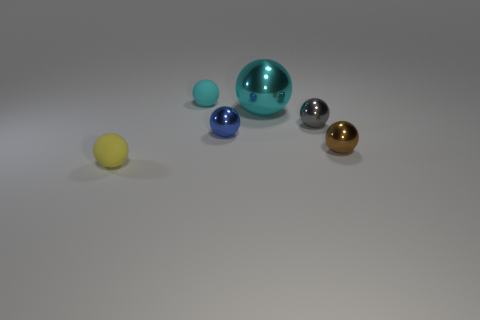How many cyan spheres must be subtracted to get 1 cyan spheres? 1 Add 3 large cyan shiny spheres. How many objects exist? 9 Subtract all brown metallic balls. How many balls are left? 5 Subtract 1 spheres. How many spheres are left? 5 Add 6 tiny rubber balls. How many tiny rubber balls exist? 8 Subtract all cyan balls. How many balls are left? 4 Subtract 0 cyan cylinders. How many objects are left? 6 Subtract all cyan spheres. Subtract all green blocks. How many spheres are left? 4 Subtract all purple cylinders. How many purple balls are left? 0 Subtract all purple metal blocks. Subtract all gray things. How many objects are left? 5 